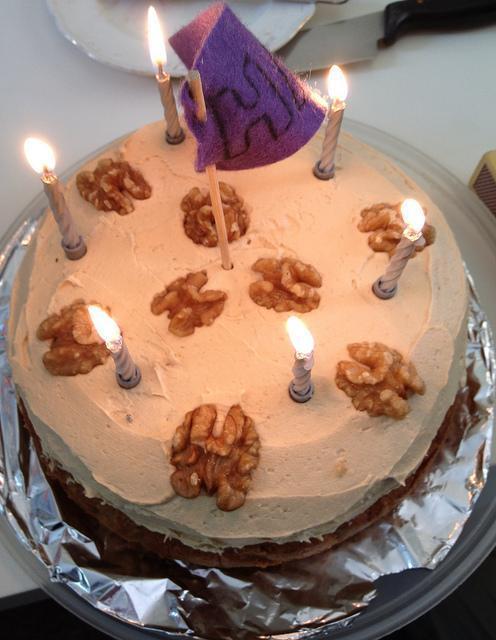How many candles?
Give a very brief answer. 6. 